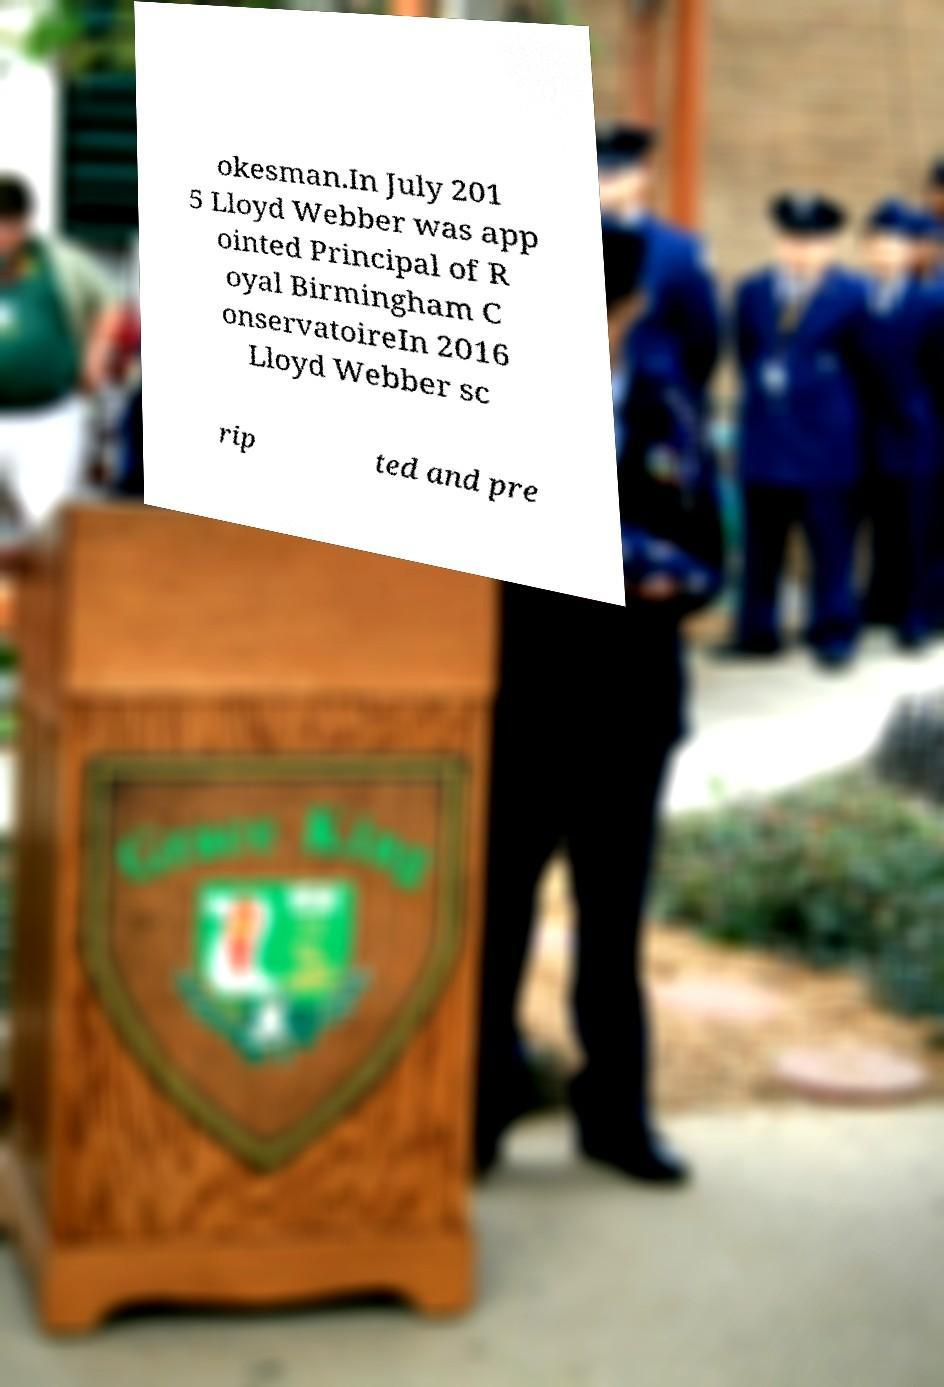Could you extract and type out the text from this image? okesman.In July 201 5 Lloyd Webber was app ointed Principal of R oyal Birmingham C onservatoireIn 2016 Lloyd Webber sc rip ted and pre 